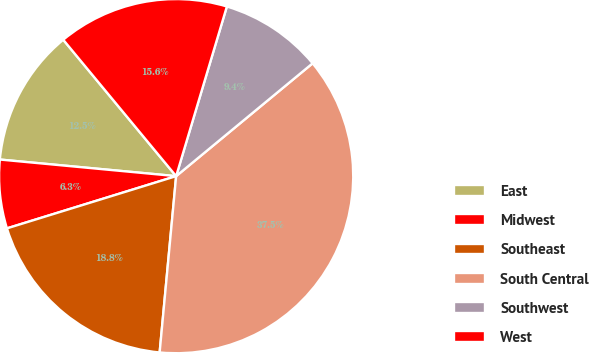Convert chart. <chart><loc_0><loc_0><loc_500><loc_500><pie_chart><fcel>East<fcel>Midwest<fcel>Southeast<fcel>South Central<fcel>Southwest<fcel>West<nl><fcel>12.5%<fcel>6.26%<fcel>18.75%<fcel>37.48%<fcel>9.38%<fcel>15.63%<nl></chart> 